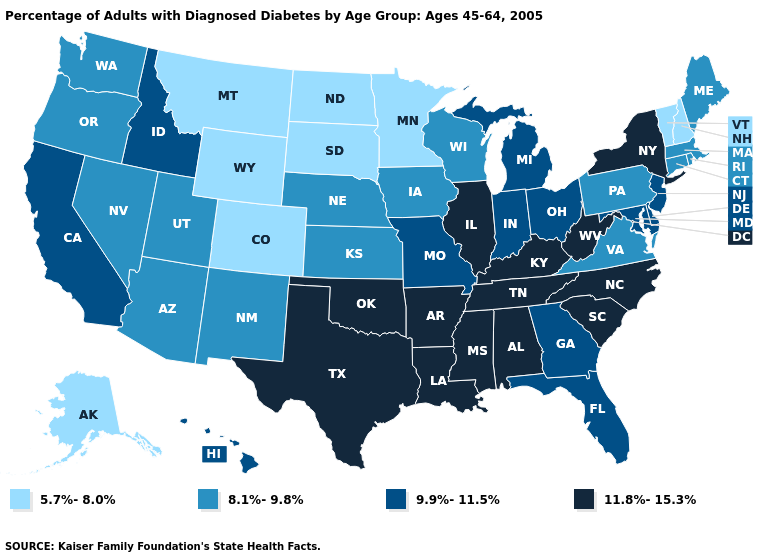Among the states that border Idaho , which have the highest value?
Concise answer only. Nevada, Oregon, Utah, Washington. Does Missouri have the same value as Indiana?
Concise answer only. Yes. What is the value of Washington?
Concise answer only. 8.1%-9.8%. Does New York have the highest value in the USA?
Write a very short answer. Yes. What is the lowest value in the USA?
Quick response, please. 5.7%-8.0%. Does Utah have the lowest value in the West?
Be succinct. No. What is the value of Alaska?
Keep it brief. 5.7%-8.0%. Name the states that have a value in the range 9.9%-11.5%?
Keep it brief. California, Delaware, Florida, Georgia, Hawaii, Idaho, Indiana, Maryland, Michigan, Missouri, New Jersey, Ohio. Does South Carolina have the same value as Idaho?
Write a very short answer. No. What is the lowest value in the USA?
Short answer required. 5.7%-8.0%. Name the states that have a value in the range 11.8%-15.3%?
Give a very brief answer. Alabama, Arkansas, Illinois, Kentucky, Louisiana, Mississippi, New York, North Carolina, Oklahoma, South Carolina, Tennessee, Texas, West Virginia. What is the highest value in states that border Nebraska?
Concise answer only. 9.9%-11.5%. What is the value of New Jersey?
Keep it brief. 9.9%-11.5%. What is the highest value in states that border Nebraska?
Give a very brief answer. 9.9%-11.5%. Does the map have missing data?
Concise answer only. No. 